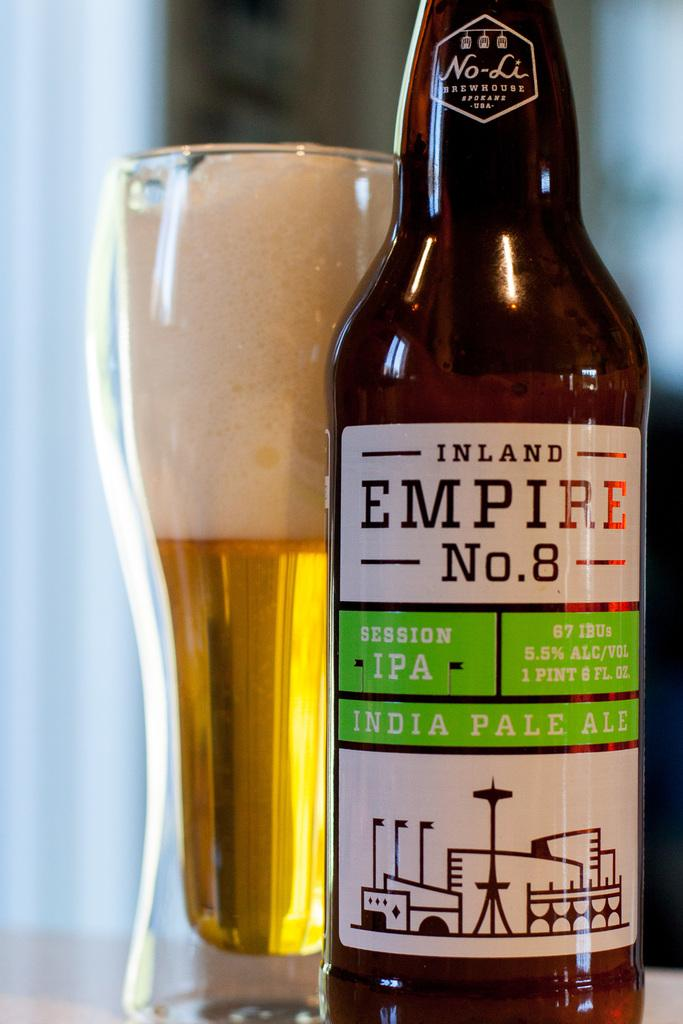<image>
Present a compact description of the photo's key features. A great tasting beer is the Inland Empire N0. 8 India pale ale. 